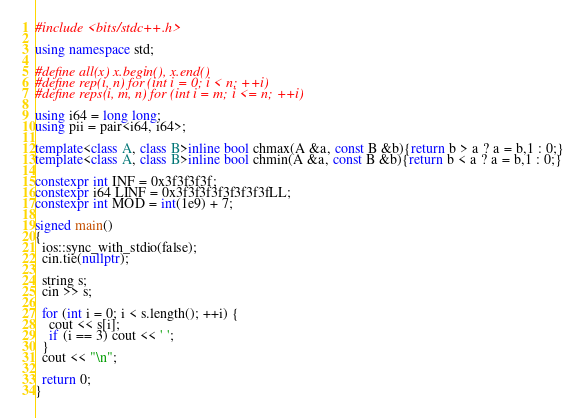<code> <loc_0><loc_0><loc_500><loc_500><_C++_>#include <bits/stdc++.h>

using namespace std;

#define all(x) x.begin(), x.end()
#define rep(i, n) for (int i = 0; i < n; ++i)
#define reps(i, m, n) for (int i = m; i <= n; ++i)

using i64 = long long;
using pii = pair<i64, i64>;

template<class A, class B>inline bool chmax(A &a, const B &b){return b > a ? a = b,1 : 0;}
template<class A, class B>inline bool chmin(A &a, const B &b){return b < a ? a = b,1 : 0;}

constexpr int INF = 0x3f3f3f3f;
constexpr i64 LINF = 0x3f3f3f3f3f3f3f3fLL;
constexpr int MOD = int(1e9) + 7;

signed main()
{
  ios::sync_with_stdio(false);
  cin.tie(nullptr);

  string s;
  cin >> s;

  for (int i = 0; i < s.length(); ++i) {
    cout << s[i];
    if (i == 3) cout << ' ';
  }
  cout << "\n";

  return 0;
}</code> 